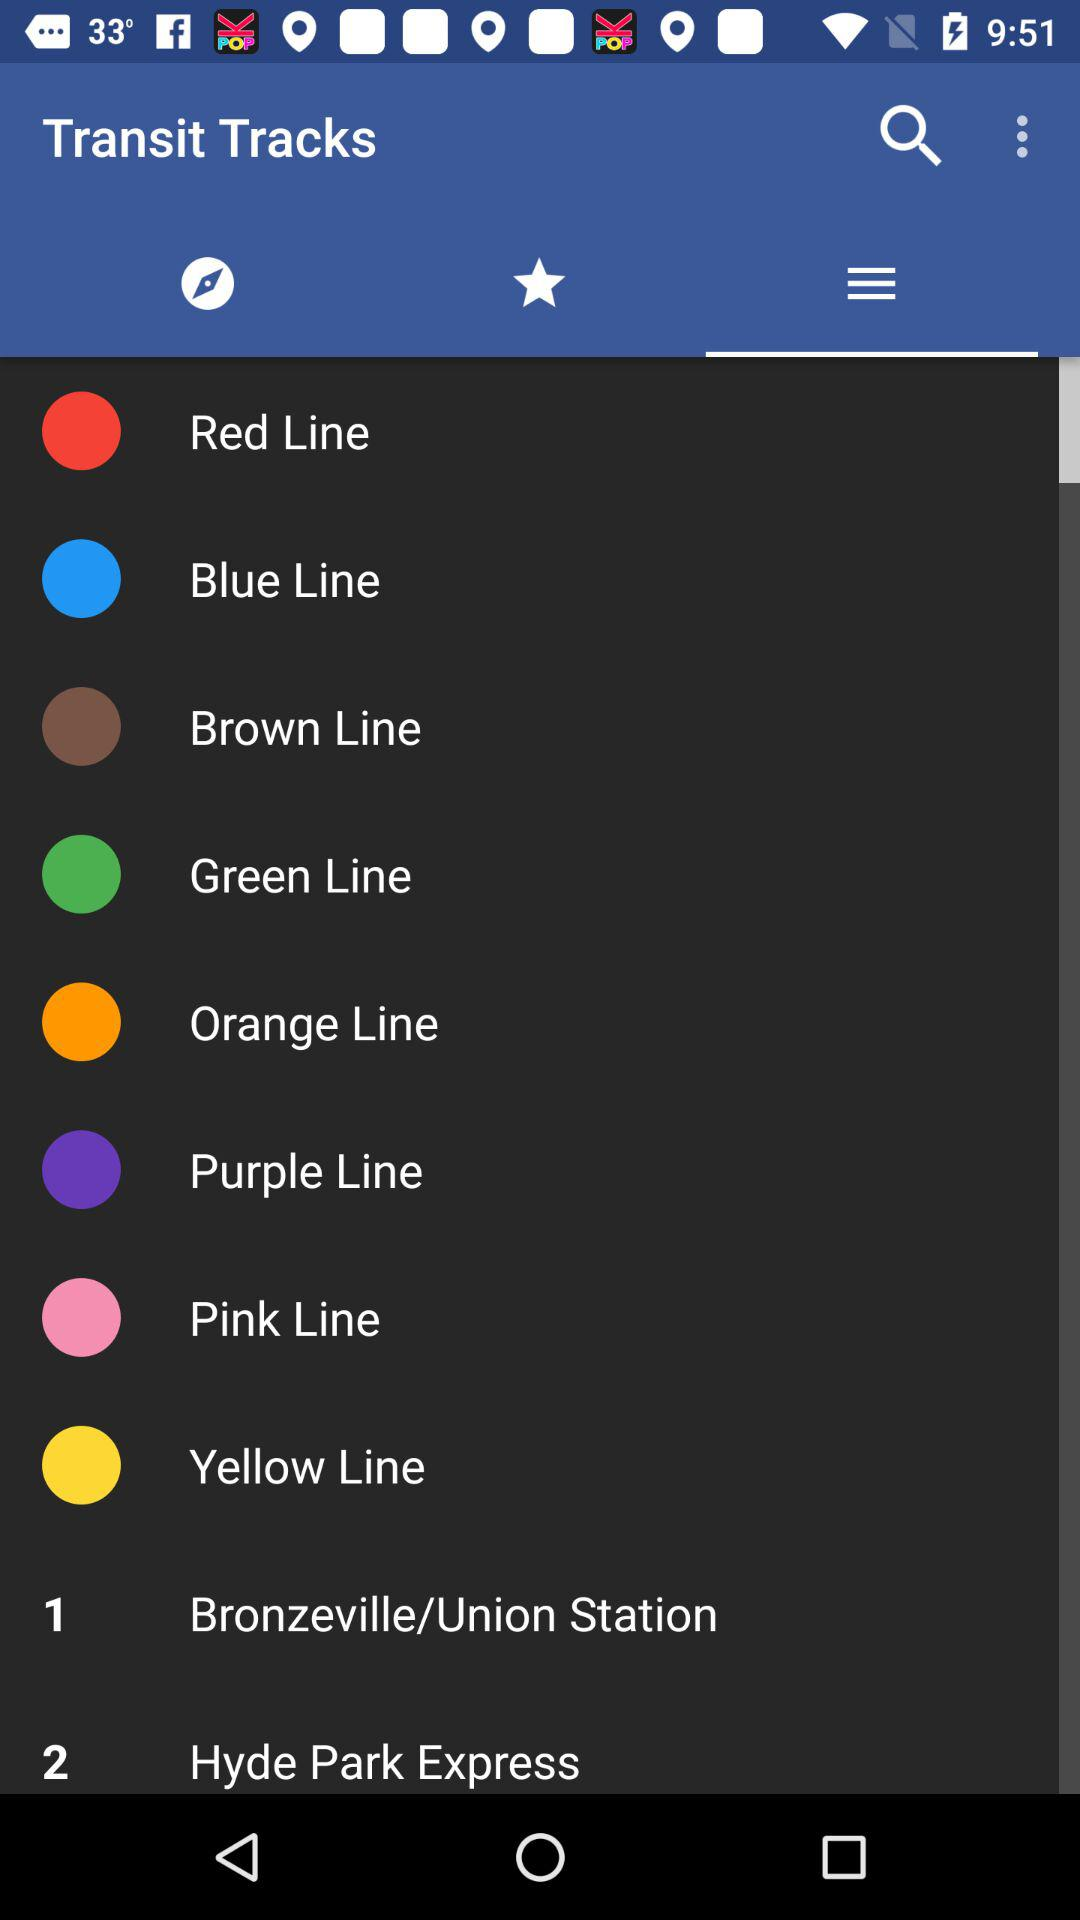How many train lines are there?
Answer the question using a single word or phrase. 8 